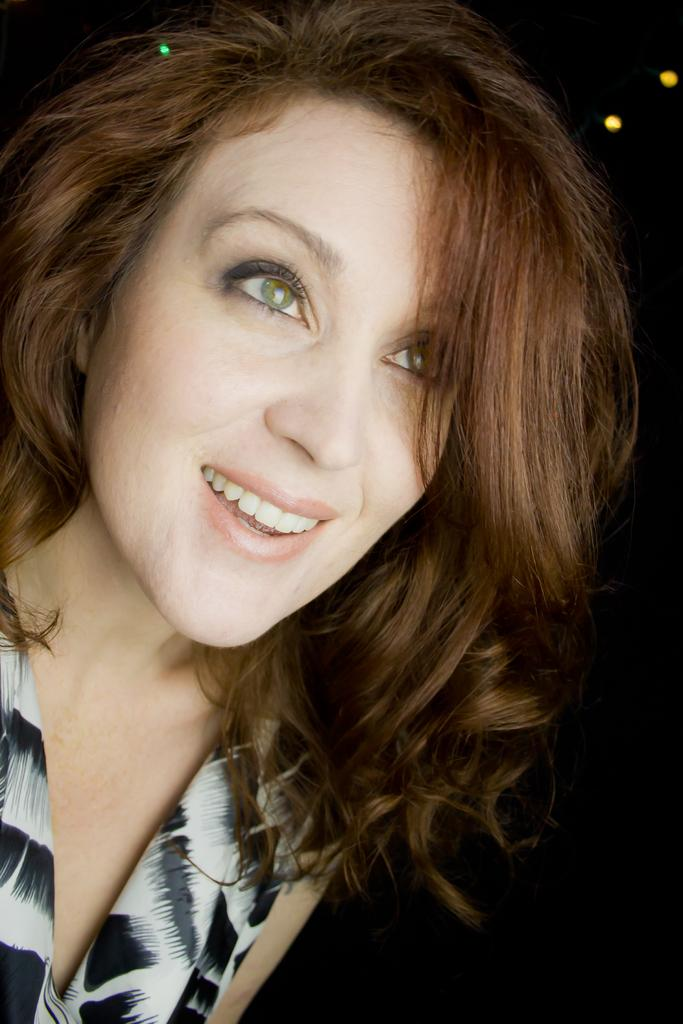Who is the main subject in the image? There is a girl in the center of the image. What type of guitar is the girl playing in the image? There is no guitar present in the image; the main subject is a girl standing in the center. 